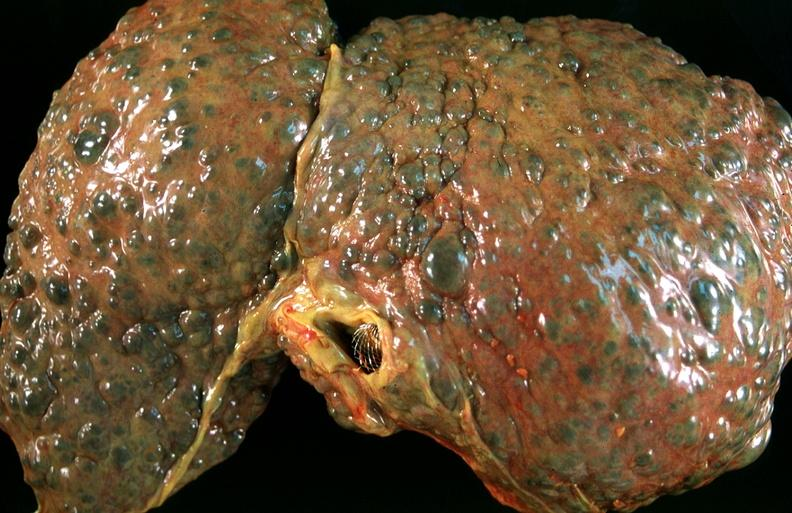s hepatobiliary present?
Answer the question using a single word or phrase. Yes 